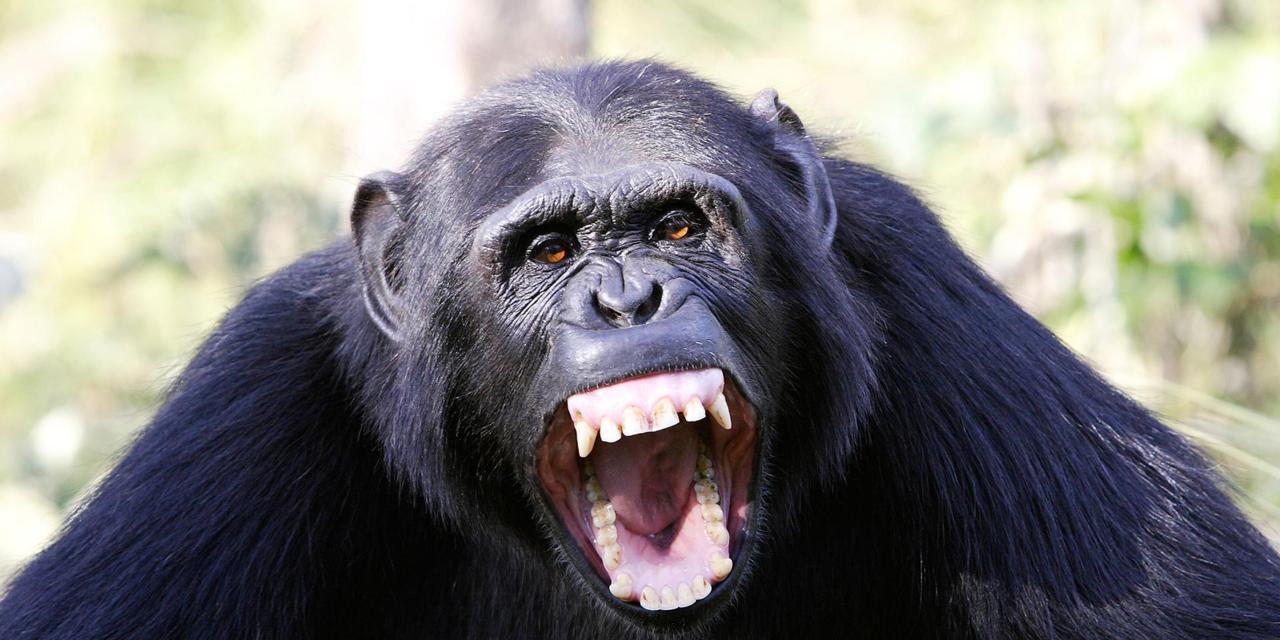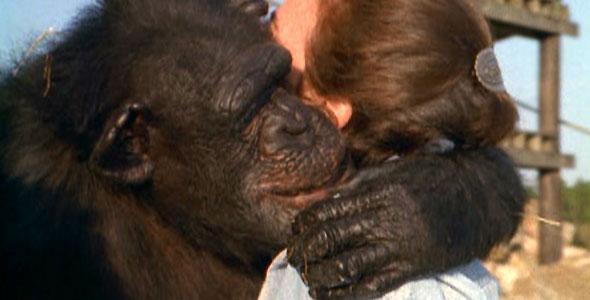The first image is the image on the left, the second image is the image on the right. Examine the images to the left and right. Is the description "There are two apes" accurate? Answer yes or no. Yes. The first image is the image on the left, the second image is the image on the right. Given the left and right images, does the statement "In the left image, one chimp is baring its teeth." hold true? Answer yes or no. Yes. 